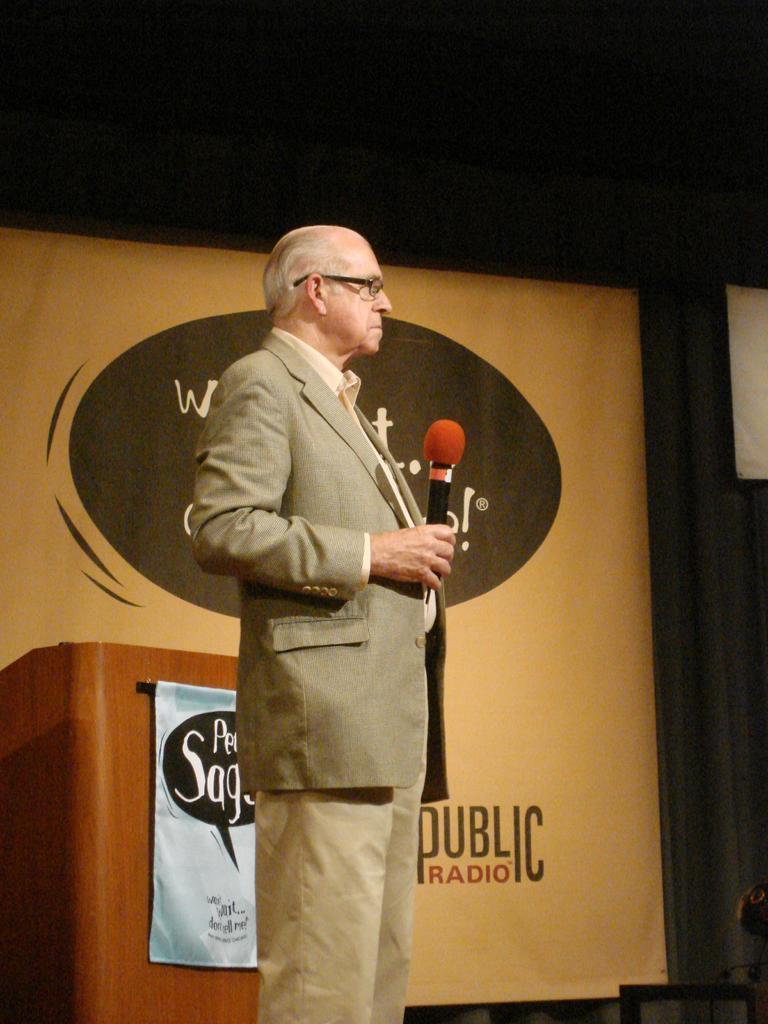In one or two sentences, can you explain what this image depicts? In this picture, In the middle there is a old man standing and he is holding a microphone which is in brown and black color, In the left side in the background there is a table which is in yellow color and there is a brown color curtain. 